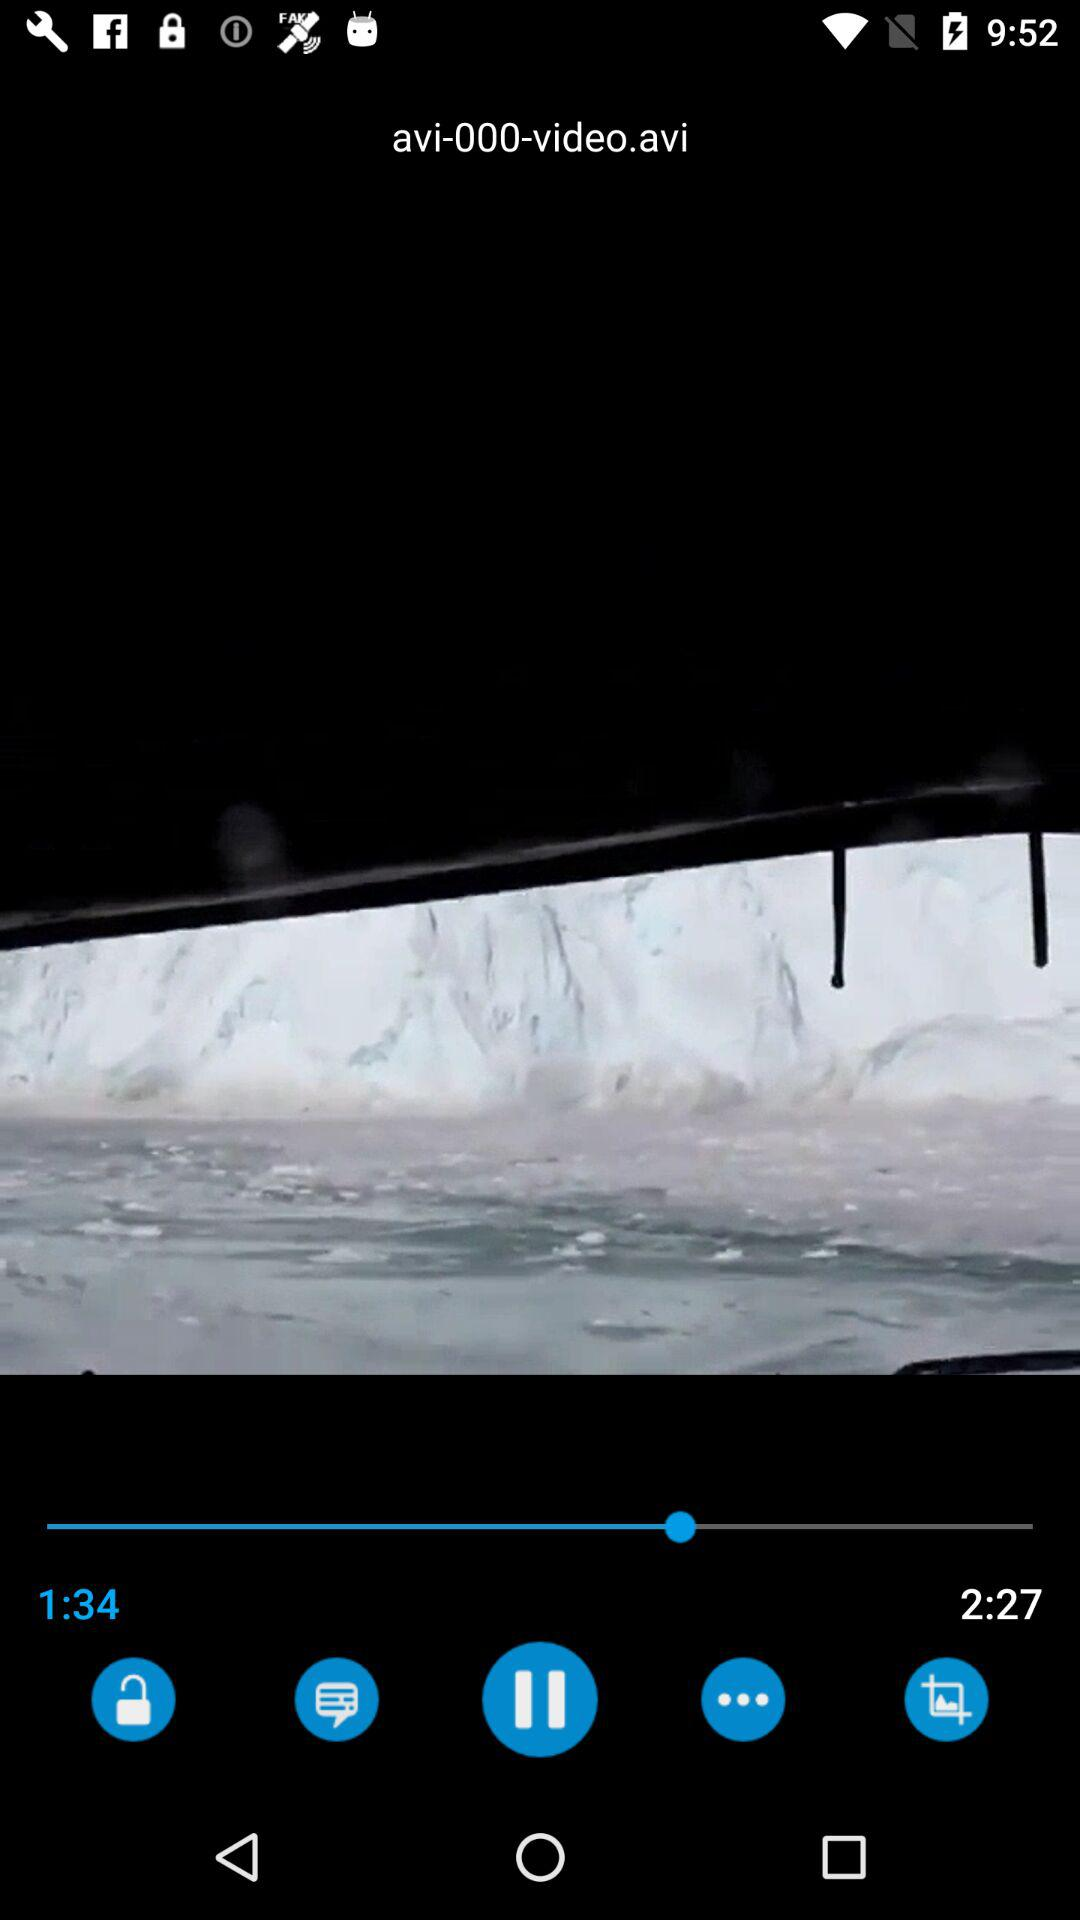How much duration of the video has been finished? The duration of the video that has been finished is 1 minute and 34 seconds. 